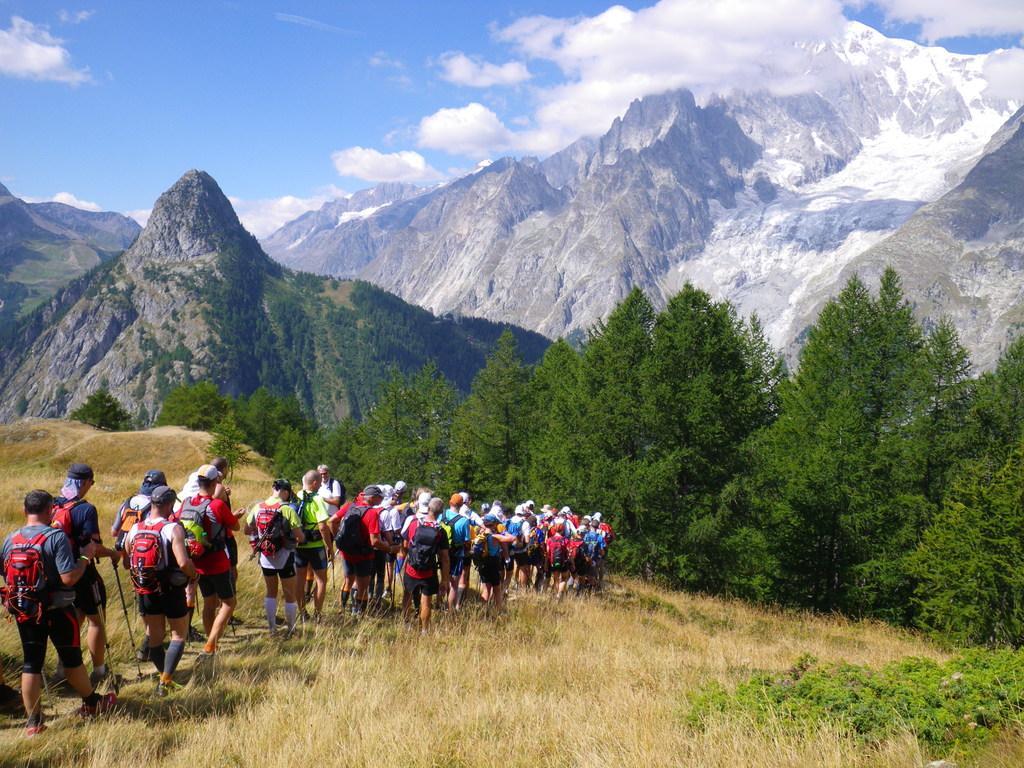Could you give a brief overview of what you see in this image? In this picture we can see mountain, sky with clouds, trees, grass and a group of people wore cap, bags holding stick in their hand and walking. 